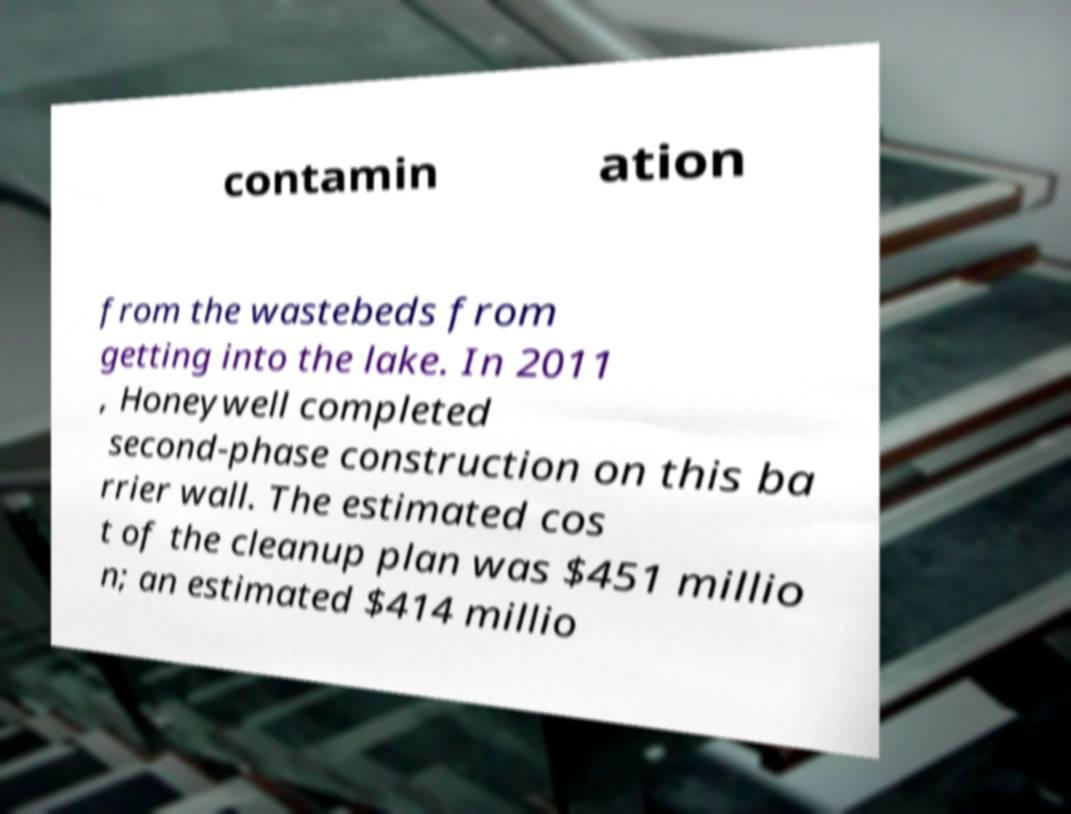Please identify and transcribe the text found in this image. contamin ation from the wastebeds from getting into the lake. In 2011 , Honeywell completed second-phase construction on this ba rrier wall. The estimated cos t of the cleanup plan was $451 millio n; an estimated $414 millio 